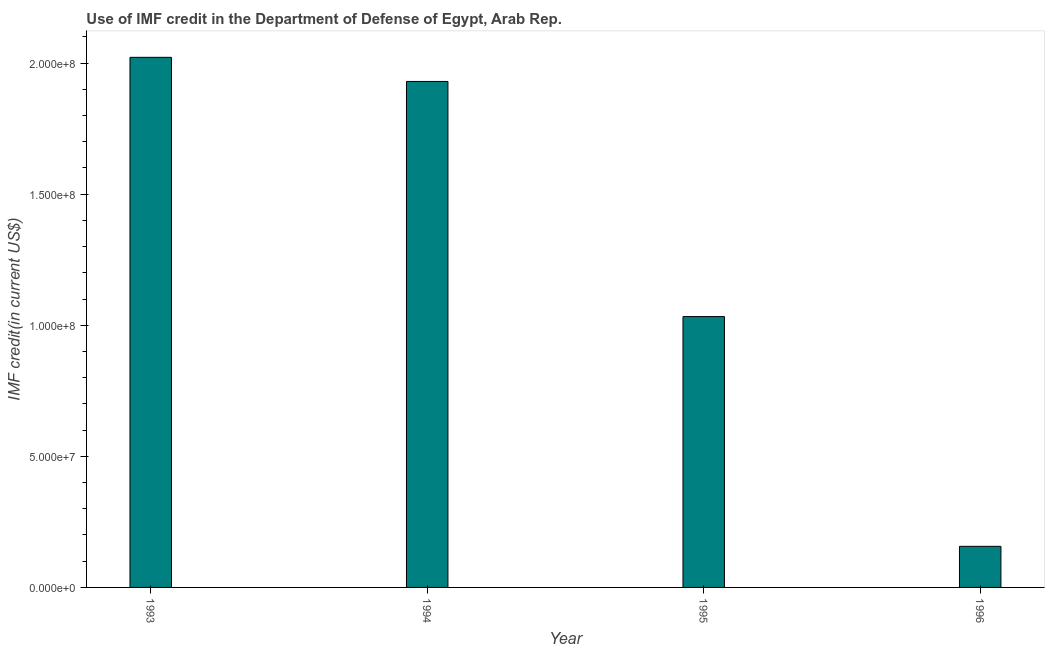Does the graph contain any zero values?
Offer a very short reply. No. What is the title of the graph?
Your response must be concise. Use of IMF credit in the Department of Defense of Egypt, Arab Rep. What is the label or title of the X-axis?
Give a very brief answer. Year. What is the label or title of the Y-axis?
Offer a terse response. IMF credit(in current US$). What is the use of imf credit in dod in 1994?
Your answer should be very brief. 1.93e+08. Across all years, what is the maximum use of imf credit in dod?
Ensure brevity in your answer.  2.02e+08. Across all years, what is the minimum use of imf credit in dod?
Offer a terse response. 1.57e+07. What is the sum of the use of imf credit in dod?
Offer a terse response. 5.14e+08. What is the difference between the use of imf credit in dod in 1993 and 1996?
Ensure brevity in your answer.  1.87e+08. What is the average use of imf credit in dod per year?
Offer a terse response. 1.29e+08. What is the median use of imf credit in dod?
Provide a short and direct response. 1.48e+08. In how many years, is the use of imf credit in dod greater than 110000000 US$?
Ensure brevity in your answer.  2. Is the difference between the use of imf credit in dod in 1993 and 1994 greater than the difference between any two years?
Your answer should be very brief. No. What is the difference between the highest and the second highest use of imf credit in dod?
Offer a very short reply. 9.20e+06. What is the difference between the highest and the lowest use of imf credit in dod?
Give a very brief answer. 1.87e+08. Are the values on the major ticks of Y-axis written in scientific E-notation?
Provide a short and direct response. Yes. What is the IMF credit(in current US$) in 1993?
Make the answer very short. 2.02e+08. What is the IMF credit(in current US$) in 1994?
Give a very brief answer. 1.93e+08. What is the IMF credit(in current US$) in 1995?
Provide a succinct answer. 1.03e+08. What is the IMF credit(in current US$) in 1996?
Your answer should be very brief. 1.57e+07. What is the difference between the IMF credit(in current US$) in 1993 and 1994?
Provide a succinct answer. 9.20e+06. What is the difference between the IMF credit(in current US$) in 1993 and 1995?
Provide a short and direct response. 9.89e+07. What is the difference between the IMF credit(in current US$) in 1993 and 1996?
Your response must be concise. 1.87e+08. What is the difference between the IMF credit(in current US$) in 1994 and 1995?
Your answer should be very brief. 8.97e+07. What is the difference between the IMF credit(in current US$) in 1994 and 1996?
Keep it short and to the point. 1.77e+08. What is the difference between the IMF credit(in current US$) in 1995 and 1996?
Offer a terse response. 8.76e+07. What is the ratio of the IMF credit(in current US$) in 1993 to that in 1994?
Ensure brevity in your answer.  1.05. What is the ratio of the IMF credit(in current US$) in 1993 to that in 1995?
Your answer should be very brief. 1.96. What is the ratio of the IMF credit(in current US$) in 1993 to that in 1996?
Provide a succinct answer. 12.9. What is the ratio of the IMF credit(in current US$) in 1994 to that in 1995?
Keep it short and to the point. 1.87. What is the ratio of the IMF credit(in current US$) in 1994 to that in 1996?
Your answer should be very brief. 12.31. What is the ratio of the IMF credit(in current US$) in 1995 to that in 1996?
Your answer should be compact. 6.59. 